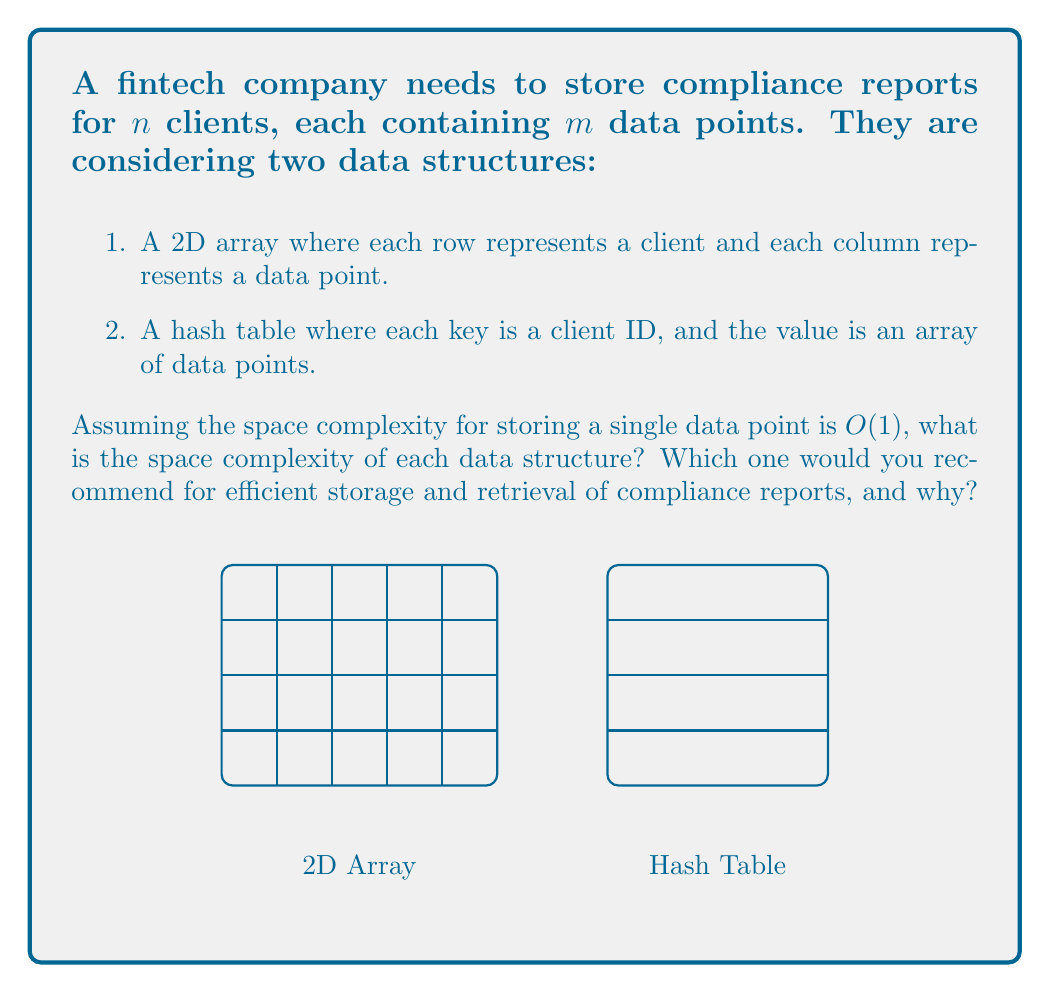Teach me how to tackle this problem. Let's analyze the space complexity of both data structures:

1. 2D Array:
   - The array has $n$ rows (clients) and $m$ columns (data points).
   - Total number of elements: $n \times m$
   - Space complexity: $O(nm)$

2. Hash Table:
   - The hash table has $n$ entries (one for each client).
   - Each entry contains an array of $m$ data points.
   - Space for hash table structure: $O(n)$
   - Space for all data points: $O(nm)$
   - Total space complexity: $O(n) + O(nm) = O(nm)$

Both data structures have the same asymptotic space complexity of $O(nm)$. However, the choice between them depends on other factors:

1. Access patterns: 
   - 2D Array: $O(1)$ access time if you know the client index and data point index.
   - Hash Table: $O(1)$ average case access time for a client's data, but you need to know the client ID.

2. Flexibility:
   - 2D Array: Fixed size, harder to add or remove clients.
   - Hash Table: More flexible for adding or removing clients.

3. Memory allocation:
   - 2D Array: Contiguous memory allocation, which can be more cache-friendly.
   - Hash Table: Non-contiguous memory allocation, which can be more flexible for large datasets.

For a fintech company dealing with compliance reports, the hash table structure is generally recommended because:
1. It allows for easy addition and removal of clients without reorganizing the entire data structure.
2. It provides fast access to a specific client's data using their unique ID.
3. It's more suitable for scenarios where the number of clients may change frequently.

However, if the number of clients is fixed and known in advance, and if cache performance is critical, the 2D array might be preferable.
Answer: Both have $O(nm)$ space complexity. Recommend hash table for flexibility and efficient client-based access. 